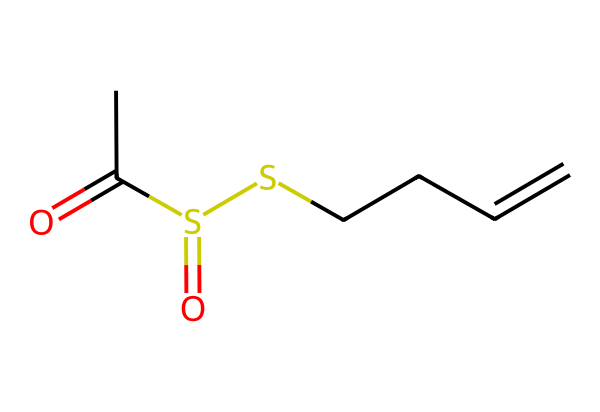What is the main functional group in allicin? The main functional group in allicin is the thioester, identifiable by the presence of the sulfur atom connected to the carbon chain with a carbonyl (C=O) adjacent to it.
Answer: thioester How many sulfur atoms are present in allicin? By analyzing the SMILES representation, we can see that there are two sulfur atoms indicated in the structure, specifically linked to carbon atoms.
Answer: two What is the total number of carbon atoms in allicin? The SMILES representation indicates there are five carbon atoms in the chain and functional groups, by counting each "C" in the representation.
Answer: five What type of chemical reaction is allicin likely involved in due to its structure? Given the presence of sulfur and double bonds in the allicin structure, it is likely to participate in redox reactions and nucleophilic substitution due to the reactive nature of sulfur.
Answer: redox reaction What property of allicin contributes to its strong aroma? The presence of sulfur in the structure is known to be responsible for strong odors, making it a key contributor to allicin's characteristic aroma.
Answer: sulfur Is allicin stable under heat? Allicin is known to be thermally unstable, as it can decompose when exposed to high temperatures, leading to the loss of its beneficial properties.
Answer: unstable What is the role of allicin in garlic's health benefits? Allicin is known for its antibacterial properties and contributes to the health benefits of garlic, which are attributed to the presence of sulfur compounds in its structure.
Answer: antibacterial 